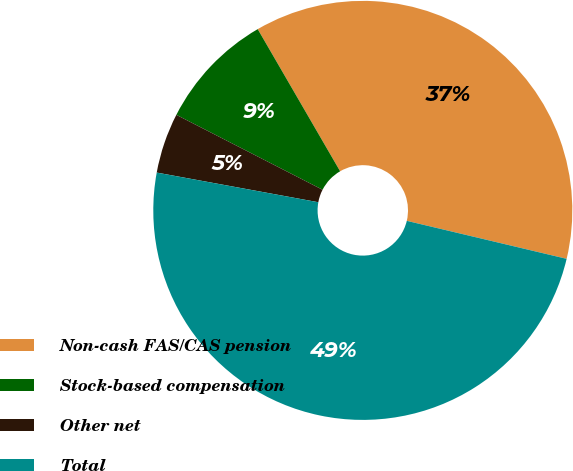<chart> <loc_0><loc_0><loc_500><loc_500><pie_chart><fcel>Non-cash FAS/CAS pension<fcel>Stock-based compensation<fcel>Other net<fcel>Total<nl><fcel>37.08%<fcel>9.1%<fcel>4.65%<fcel>49.18%<nl></chart> 